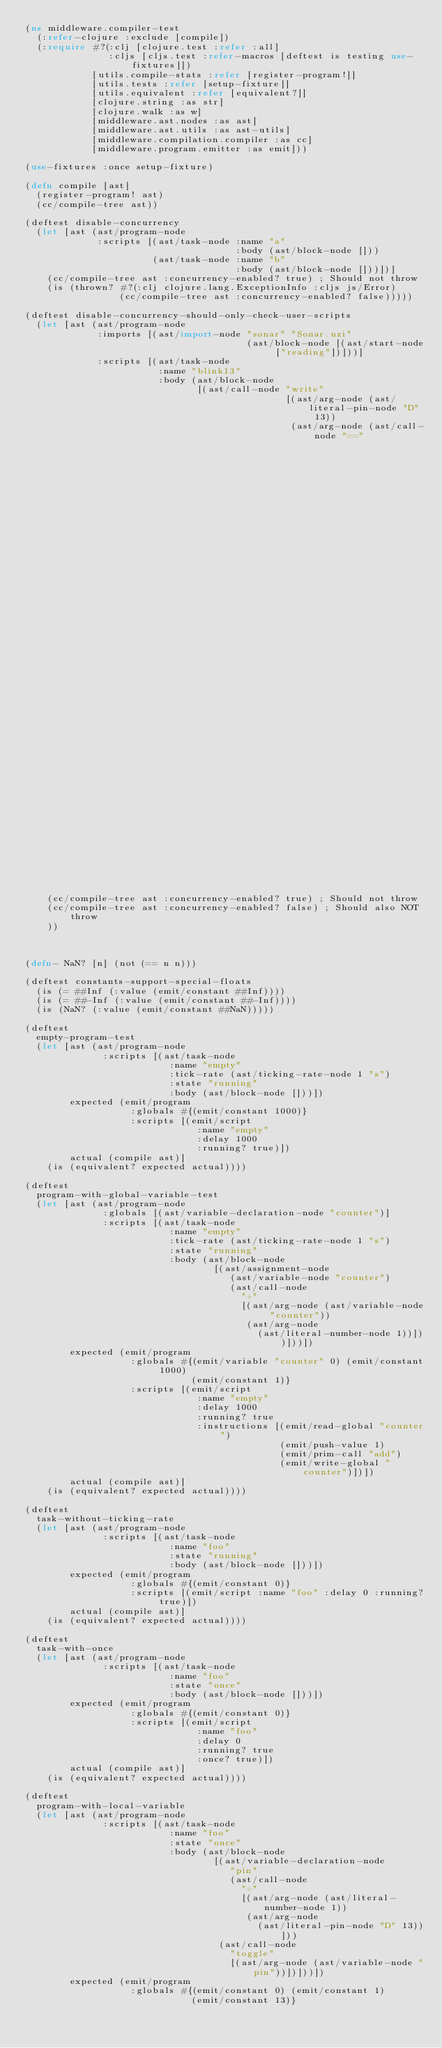Convert code to text. <code><loc_0><loc_0><loc_500><loc_500><_Clojure_>(ns middleware.compiler-test
  (:refer-clojure :exclude [compile])
  (:require #?(:clj [clojure.test :refer :all]
               :cljs [cljs.test :refer-macros [deftest is testing use-fixtures]])
            [utils.compile-stats :refer [register-program!]]
            [utils.tests :refer [setup-fixture]]
            [utils.equivalent :refer [equivalent?]]
            [clojure.string :as str]
            [clojure.walk :as w]
            [middleware.ast.nodes :as ast]
            [middleware.ast.utils :as ast-utils]
            [middleware.compilation.compiler :as cc]
            [middleware.program.emitter :as emit]))

(use-fixtures :once setup-fixture)

(defn compile [ast]
  (register-program! ast)
  (cc/compile-tree ast))

(deftest disable-concurrency
  (let [ast (ast/program-node
             :scripts [(ast/task-node :name "a"
                                      :body (ast/block-node []))
                       (ast/task-node :name "b"
                                      :body (ast/block-node []))])]
    (cc/compile-tree ast :concurrency-enabled? true) ; Should not throw
    (is (thrown? #?(:clj clojure.lang.ExceptionInfo :cljs js/Error)
                 (cc/compile-tree ast :concurrency-enabled? false)))))

(deftest disable-concurrency-should-only-check-user-scripts
  (let [ast (ast/program-node
             :imports [(ast/import-node "sonar" "Sonar.uzi"
                                        (ast/block-node [(ast/start-node ["reading"])]))]
             :scripts [(ast/task-node
                        :name "blink13"
                        :body (ast/block-node
                               [(ast/call-node "write"
                                               [(ast/arg-node (ast/literal-pin-node "D" 13))
                                                (ast/arg-node (ast/call-node "=="
                                                                             [(ast/arg-node (ast/call-node "sonar.distance_cm" []))
                                                                              (ast/arg-node (ast/literal-number-node 1))]))])]))])]
    (cc/compile-tree ast :concurrency-enabled? true) ; Should not throw 
    (cc/compile-tree ast :concurrency-enabled? false) ; Should also NOT throw
    ))



(defn- NaN? [n] (not (== n n)))

(deftest constants-support-special-floats
  (is (= ##Inf (:value (emit/constant ##Inf))))
  (is (= ##-Inf (:value (emit/constant ##-Inf))))
  (is (NaN? (:value (emit/constant ##NaN)))))

(deftest
  empty-program-test
  (let [ast (ast/program-node
              :scripts [(ast/task-node
                          :name "empty"
                          :tick-rate (ast/ticking-rate-node 1 "s")
                          :state "running"
                          :body (ast/block-node []))])
        expected (emit/program
                   :globals #{(emit/constant 1000)}
                   :scripts [(emit/script
                               :name "empty"
                               :delay 1000
                               :running? true)])
        actual (compile ast)]
    (is (equivalent? expected actual))))

(deftest
  program-with-global-variable-test
  (let [ast (ast/program-node
              :globals [(ast/variable-declaration-node "counter")]
              :scripts [(ast/task-node
                          :name "empty"
                          :tick-rate (ast/ticking-rate-node 1 "s")
                          :state "running"
                          :body (ast/block-node
                                  [(ast/assignment-node
                                     (ast/variable-node "counter")
                                     (ast/call-node
                                       "+"
                                       [(ast/arg-node (ast/variable-node "counter"))
                                        (ast/arg-node
                                          (ast/literal-number-node 1))]))]))])
        expected (emit/program
                   :globals #{(emit/variable "counter" 0) (emit/constant 1000)
                              (emit/constant 1)}
                   :scripts [(emit/script
                               :name "empty"
                               :delay 1000
                               :running? true
                               :instructions [(emit/read-global "counter")
                                              (emit/push-value 1)
                                              (emit/prim-call "add")
                                              (emit/write-global "counter")])])
        actual (compile ast)]
    (is (equivalent? expected actual))))

(deftest
  task-without-ticking-rate
  (let [ast (ast/program-node
              :scripts [(ast/task-node
                          :name "foo"
                          :state "running"
                          :body (ast/block-node []))])
        expected (emit/program
                   :globals #{(emit/constant 0)}
                   :scripts [(emit/script :name "foo" :delay 0 :running? true)])
        actual (compile ast)]
    (is (equivalent? expected actual))))

(deftest
  task-with-once
  (let [ast (ast/program-node
              :scripts [(ast/task-node
                          :name "foo"
                          :state "once"
                          :body (ast/block-node []))])
        expected (emit/program
                   :globals #{(emit/constant 0)}
                   :scripts [(emit/script
                               :name "foo"
                               :delay 0
                               :running? true
                               :once? true)])
        actual (compile ast)]
    (is (equivalent? expected actual))))

(deftest
  program-with-local-variable
  (let [ast (ast/program-node
              :scripts [(ast/task-node
                          :name "foo"
                          :state "once"
                          :body (ast/block-node
                                  [(ast/variable-declaration-node
                                     "pin"
                                     (ast/call-node
                                       "+"
                                       [(ast/arg-node (ast/literal-number-node 1))
                                        (ast/arg-node
                                          (ast/literal-pin-node "D" 13))]))
                                   (ast/call-node
                                     "toggle"
                                     [(ast/arg-node (ast/variable-node "pin"))])]))])
        expected (emit/program
                   :globals #{(emit/constant 0) (emit/constant 1)
                              (emit/constant 13)}</code> 